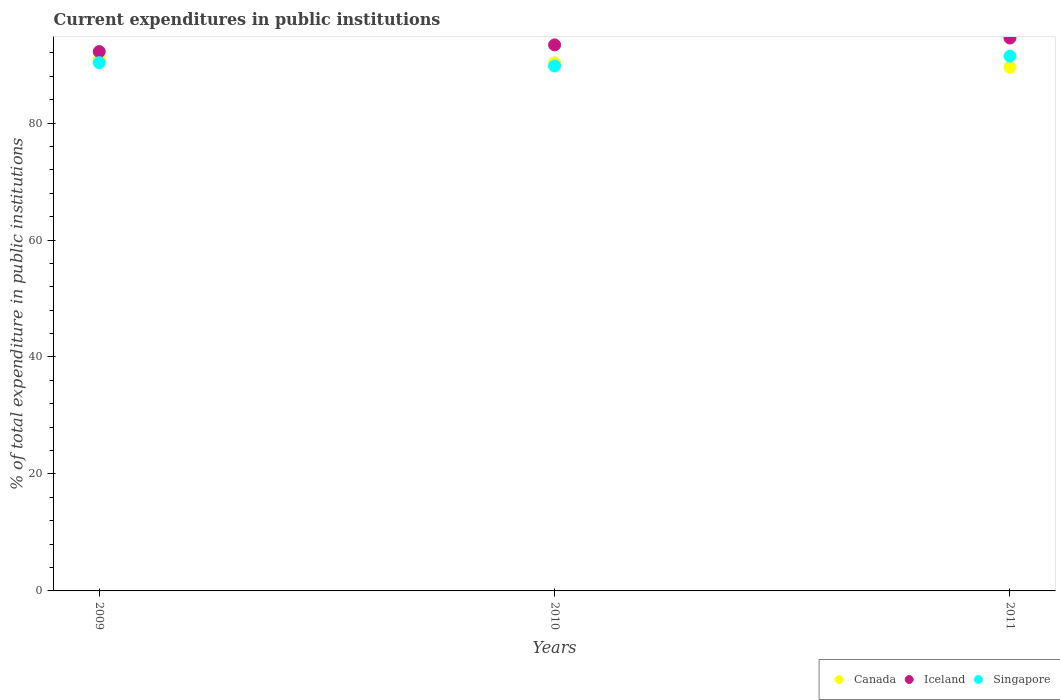How many different coloured dotlines are there?
Provide a short and direct response. 3. Is the number of dotlines equal to the number of legend labels?
Your answer should be very brief. Yes. What is the current expenditures in public institutions in Singapore in 2011?
Provide a short and direct response. 91.44. Across all years, what is the maximum current expenditures in public institutions in Canada?
Give a very brief answer. 90.93. Across all years, what is the minimum current expenditures in public institutions in Canada?
Make the answer very short. 89.55. In which year was the current expenditures in public institutions in Iceland maximum?
Ensure brevity in your answer.  2011. In which year was the current expenditures in public institutions in Canada minimum?
Keep it short and to the point. 2011. What is the total current expenditures in public institutions in Singapore in the graph?
Provide a succinct answer. 271.52. What is the difference between the current expenditures in public institutions in Canada in 2010 and that in 2011?
Offer a very short reply. 0.74. What is the difference between the current expenditures in public institutions in Canada in 2011 and the current expenditures in public institutions in Iceland in 2009?
Your answer should be very brief. -2.67. What is the average current expenditures in public institutions in Iceland per year?
Give a very brief answer. 93.37. In the year 2009, what is the difference between the current expenditures in public institutions in Singapore and current expenditures in public institutions in Iceland?
Make the answer very short. -1.89. In how many years, is the current expenditures in public institutions in Singapore greater than 16 %?
Your response must be concise. 3. What is the ratio of the current expenditures in public institutions in Canada in 2010 to that in 2011?
Ensure brevity in your answer.  1.01. Is the current expenditures in public institutions in Iceland in 2010 less than that in 2011?
Keep it short and to the point. Yes. Is the difference between the current expenditures in public institutions in Singapore in 2009 and 2011 greater than the difference between the current expenditures in public institutions in Iceland in 2009 and 2011?
Offer a terse response. Yes. What is the difference between the highest and the second highest current expenditures in public institutions in Canada?
Your response must be concise. 0.64. What is the difference between the highest and the lowest current expenditures in public institutions in Singapore?
Provide a succinct answer. 1.69. Is the sum of the current expenditures in public institutions in Iceland in 2009 and 2011 greater than the maximum current expenditures in public institutions in Singapore across all years?
Offer a terse response. Yes. Is it the case that in every year, the sum of the current expenditures in public institutions in Canada and current expenditures in public institutions in Singapore  is greater than the current expenditures in public institutions in Iceland?
Provide a succinct answer. Yes. Is the current expenditures in public institutions in Singapore strictly less than the current expenditures in public institutions in Iceland over the years?
Provide a succinct answer. Yes. How many dotlines are there?
Your answer should be very brief. 3. How many years are there in the graph?
Your response must be concise. 3. Does the graph contain grids?
Give a very brief answer. No. Where does the legend appear in the graph?
Your answer should be compact. Bottom right. What is the title of the graph?
Offer a very short reply. Current expenditures in public institutions. What is the label or title of the X-axis?
Your answer should be compact. Years. What is the label or title of the Y-axis?
Make the answer very short. % of total expenditure in public institutions. What is the % of total expenditure in public institutions in Canada in 2009?
Your answer should be compact. 90.93. What is the % of total expenditure in public institutions in Iceland in 2009?
Keep it short and to the point. 92.22. What is the % of total expenditure in public institutions of Singapore in 2009?
Provide a short and direct response. 90.32. What is the % of total expenditure in public institutions in Canada in 2010?
Your answer should be very brief. 90.29. What is the % of total expenditure in public institutions of Iceland in 2010?
Provide a succinct answer. 93.36. What is the % of total expenditure in public institutions in Singapore in 2010?
Your answer should be very brief. 89.75. What is the % of total expenditure in public institutions in Canada in 2011?
Give a very brief answer. 89.55. What is the % of total expenditure in public institutions of Iceland in 2011?
Offer a terse response. 94.54. What is the % of total expenditure in public institutions in Singapore in 2011?
Make the answer very short. 91.44. Across all years, what is the maximum % of total expenditure in public institutions of Canada?
Give a very brief answer. 90.93. Across all years, what is the maximum % of total expenditure in public institutions of Iceland?
Make the answer very short. 94.54. Across all years, what is the maximum % of total expenditure in public institutions in Singapore?
Ensure brevity in your answer.  91.44. Across all years, what is the minimum % of total expenditure in public institutions in Canada?
Offer a terse response. 89.55. Across all years, what is the minimum % of total expenditure in public institutions in Iceland?
Make the answer very short. 92.22. Across all years, what is the minimum % of total expenditure in public institutions in Singapore?
Give a very brief answer. 89.75. What is the total % of total expenditure in public institutions in Canada in the graph?
Keep it short and to the point. 270.77. What is the total % of total expenditure in public institutions in Iceland in the graph?
Offer a very short reply. 280.12. What is the total % of total expenditure in public institutions in Singapore in the graph?
Ensure brevity in your answer.  271.52. What is the difference between the % of total expenditure in public institutions in Canada in 2009 and that in 2010?
Give a very brief answer. 0.64. What is the difference between the % of total expenditure in public institutions of Iceland in 2009 and that in 2010?
Ensure brevity in your answer.  -1.14. What is the difference between the % of total expenditure in public institutions of Canada in 2009 and that in 2011?
Provide a short and direct response. 1.37. What is the difference between the % of total expenditure in public institutions of Iceland in 2009 and that in 2011?
Provide a succinct answer. -2.32. What is the difference between the % of total expenditure in public institutions in Singapore in 2009 and that in 2011?
Your response must be concise. -1.12. What is the difference between the % of total expenditure in public institutions in Canada in 2010 and that in 2011?
Offer a very short reply. 0.74. What is the difference between the % of total expenditure in public institutions in Iceland in 2010 and that in 2011?
Your answer should be very brief. -1.17. What is the difference between the % of total expenditure in public institutions of Singapore in 2010 and that in 2011?
Give a very brief answer. -1.69. What is the difference between the % of total expenditure in public institutions in Canada in 2009 and the % of total expenditure in public institutions in Iceland in 2010?
Make the answer very short. -2.44. What is the difference between the % of total expenditure in public institutions in Canada in 2009 and the % of total expenditure in public institutions in Singapore in 2010?
Offer a terse response. 1.17. What is the difference between the % of total expenditure in public institutions of Iceland in 2009 and the % of total expenditure in public institutions of Singapore in 2010?
Offer a very short reply. 2.46. What is the difference between the % of total expenditure in public institutions of Canada in 2009 and the % of total expenditure in public institutions of Iceland in 2011?
Provide a short and direct response. -3.61. What is the difference between the % of total expenditure in public institutions of Canada in 2009 and the % of total expenditure in public institutions of Singapore in 2011?
Provide a succinct answer. -0.52. What is the difference between the % of total expenditure in public institutions of Iceland in 2009 and the % of total expenditure in public institutions of Singapore in 2011?
Your answer should be very brief. 0.78. What is the difference between the % of total expenditure in public institutions of Canada in 2010 and the % of total expenditure in public institutions of Iceland in 2011?
Keep it short and to the point. -4.25. What is the difference between the % of total expenditure in public institutions of Canada in 2010 and the % of total expenditure in public institutions of Singapore in 2011?
Provide a succinct answer. -1.15. What is the difference between the % of total expenditure in public institutions of Iceland in 2010 and the % of total expenditure in public institutions of Singapore in 2011?
Your answer should be very brief. 1.92. What is the average % of total expenditure in public institutions in Canada per year?
Provide a short and direct response. 90.26. What is the average % of total expenditure in public institutions in Iceland per year?
Your response must be concise. 93.37. What is the average % of total expenditure in public institutions in Singapore per year?
Ensure brevity in your answer.  90.51. In the year 2009, what is the difference between the % of total expenditure in public institutions of Canada and % of total expenditure in public institutions of Iceland?
Your response must be concise. -1.29. In the year 2009, what is the difference between the % of total expenditure in public institutions in Canada and % of total expenditure in public institutions in Singapore?
Ensure brevity in your answer.  0.6. In the year 2009, what is the difference between the % of total expenditure in public institutions of Iceland and % of total expenditure in public institutions of Singapore?
Offer a very short reply. 1.89. In the year 2010, what is the difference between the % of total expenditure in public institutions of Canada and % of total expenditure in public institutions of Iceland?
Ensure brevity in your answer.  -3.07. In the year 2010, what is the difference between the % of total expenditure in public institutions in Canada and % of total expenditure in public institutions in Singapore?
Your response must be concise. 0.53. In the year 2010, what is the difference between the % of total expenditure in public institutions of Iceland and % of total expenditure in public institutions of Singapore?
Provide a succinct answer. 3.61. In the year 2011, what is the difference between the % of total expenditure in public institutions in Canada and % of total expenditure in public institutions in Iceland?
Offer a very short reply. -4.98. In the year 2011, what is the difference between the % of total expenditure in public institutions in Canada and % of total expenditure in public institutions in Singapore?
Keep it short and to the point. -1.89. In the year 2011, what is the difference between the % of total expenditure in public institutions of Iceland and % of total expenditure in public institutions of Singapore?
Give a very brief answer. 3.09. What is the ratio of the % of total expenditure in public institutions in Canada in 2009 to that in 2010?
Your answer should be compact. 1.01. What is the ratio of the % of total expenditure in public institutions of Iceland in 2009 to that in 2010?
Make the answer very short. 0.99. What is the ratio of the % of total expenditure in public institutions of Singapore in 2009 to that in 2010?
Ensure brevity in your answer.  1.01. What is the ratio of the % of total expenditure in public institutions of Canada in 2009 to that in 2011?
Give a very brief answer. 1.02. What is the ratio of the % of total expenditure in public institutions in Iceland in 2009 to that in 2011?
Your response must be concise. 0.98. What is the ratio of the % of total expenditure in public institutions of Canada in 2010 to that in 2011?
Your answer should be very brief. 1.01. What is the ratio of the % of total expenditure in public institutions of Iceland in 2010 to that in 2011?
Offer a terse response. 0.99. What is the ratio of the % of total expenditure in public institutions of Singapore in 2010 to that in 2011?
Provide a short and direct response. 0.98. What is the difference between the highest and the second highest % of total expenditure in public institutions of Canada?
Ensure brevity in your answer.  0.64. What is the difference between the highest and the second highest % of total expenditure in public institutions in Iceland?
Keep it short and to the point. 1.17. What is the difference between the highest and the second highest % of total expenditure in public institutions of Singapore?
Your response must be concise. 1.12. What is the difference between the highest and the lowest % of total expenditure in public institutions in Canada?
Give a very brief answer. 1.37. What is the difference between the highest and the lowest % of total expenditure in public institutions of Iceland?
Your answer should be compact. 2.32. What is the difference between the highest and the lowest % of total expenditure in public institutions in Singapore?
Provide a short and direct response. 1.69. 